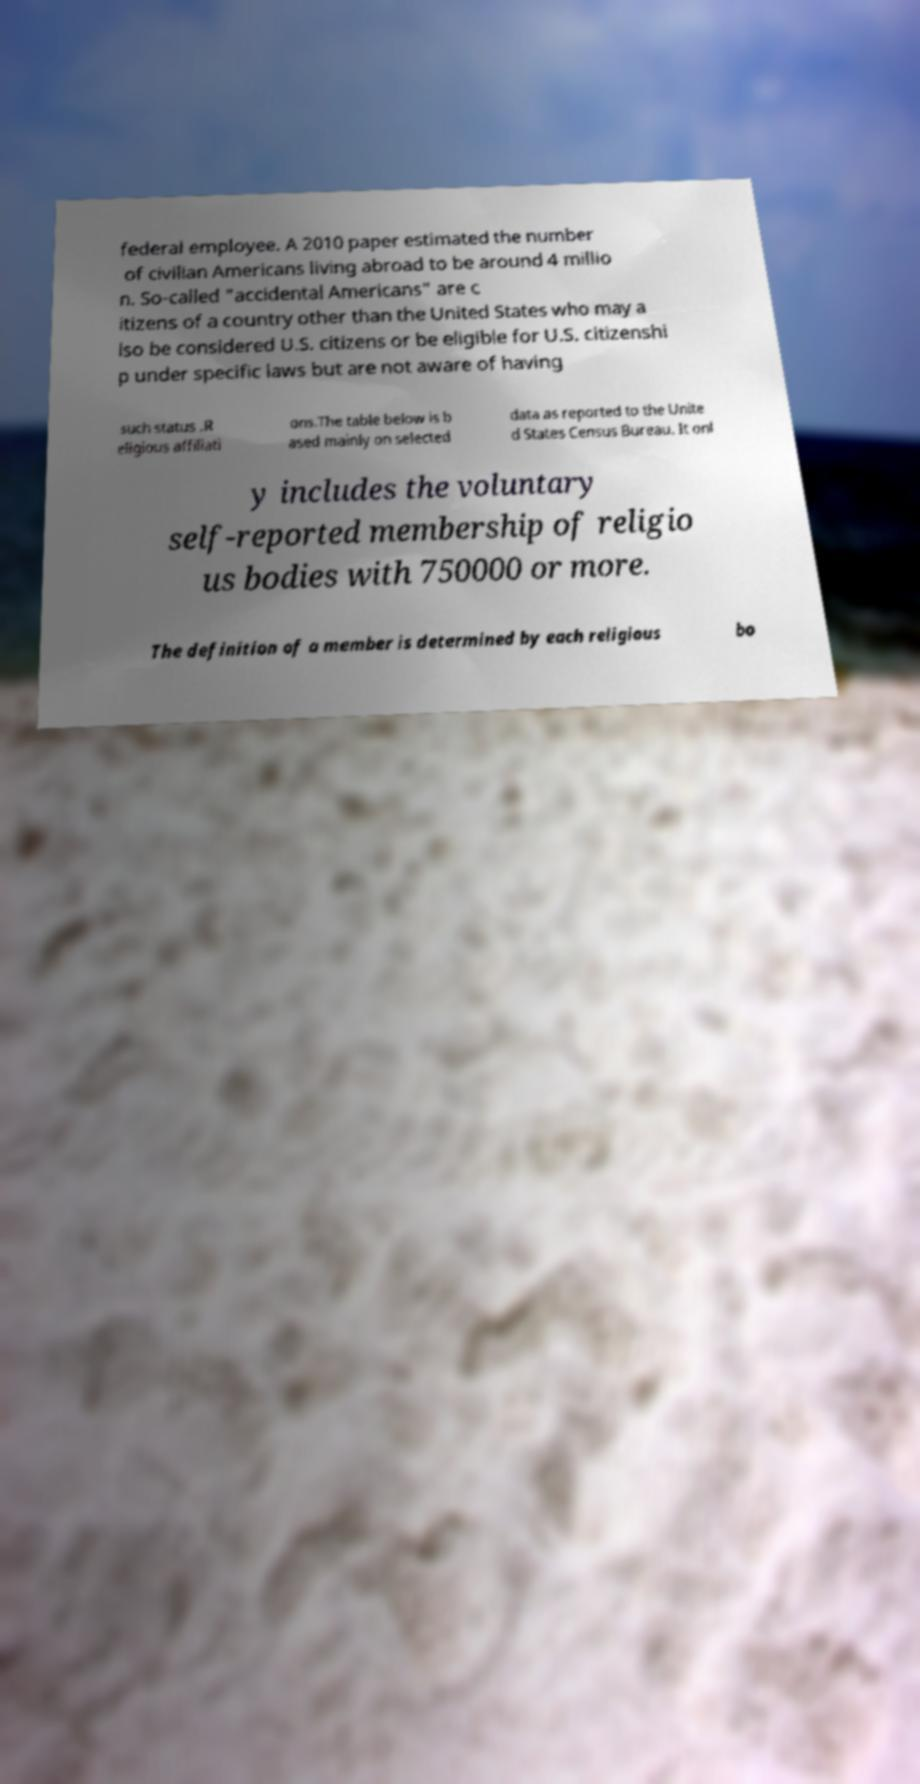There's text embedded in this image that I need extracted. Can you transcribe it verbatim? federal employee. A 2010 paper estimated the number of civilian Americans living abroad to be around 4 millio n. So-called "accidental Americans" are c itizens of a country other than the United States who may a lso be considered U.S. citizens or be eligible for U.S. citizenshi p under specific laws but are not aware of having such status .R eligious affiliati ons.The table below is b ased mainly on selected data as reported to the Unite d States Census Bureau. It onl y includes the voluntary self-reported membership of religio us bodies with 750000 or more. The definition of a member is determined by each religious bo 